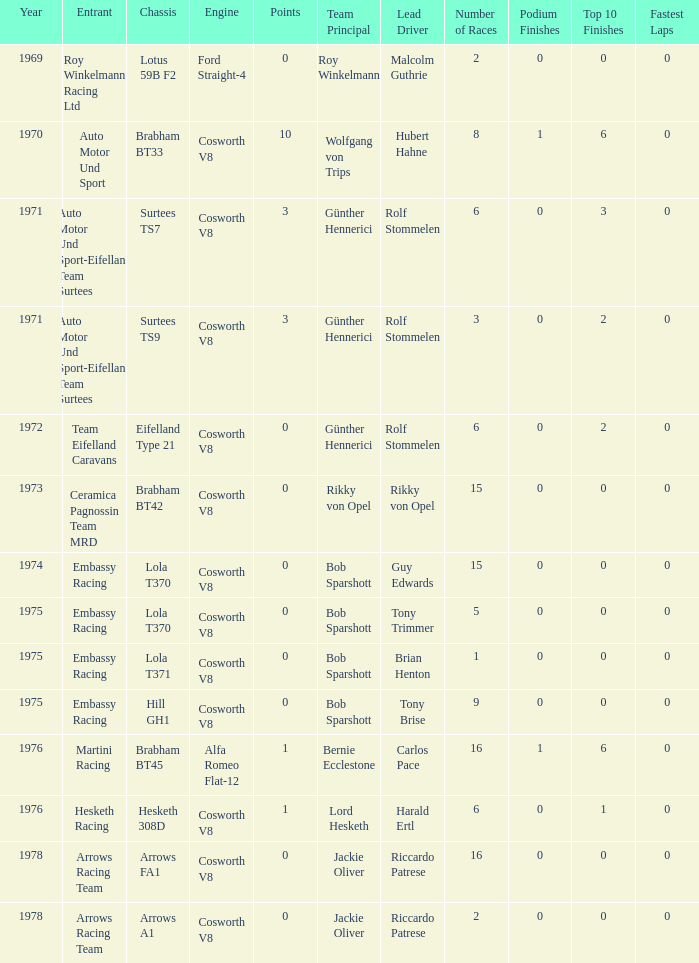What was the total amount of points in 1978 with a Chassis of arrows fa1? 0.0. 